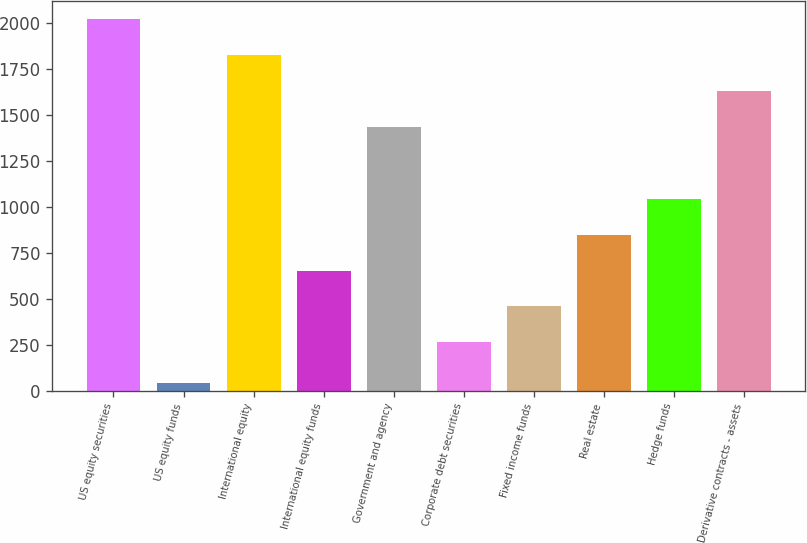<chart> <loc_0><loc_0><loc_500><loc_500><bar_chart><fcel>US equity securities<fcel>US equity funds<fcel>International equity<fcel>International equity funds<fcel>Government and agency<fcel>Corporate debt securities<fcel>Fixed income funds<fcel>Real estate<fcel>Hedge funds<fcel>Derivative contracts - assets<nl><fcel>2018.9<fcel>40<fcel>1823.8<fcel>653.2<fcel>1433.6<fcel>263<fcel>458.1<fcel>848.3<fcel>1043.4<fcel>1628.7<nl></chart> 